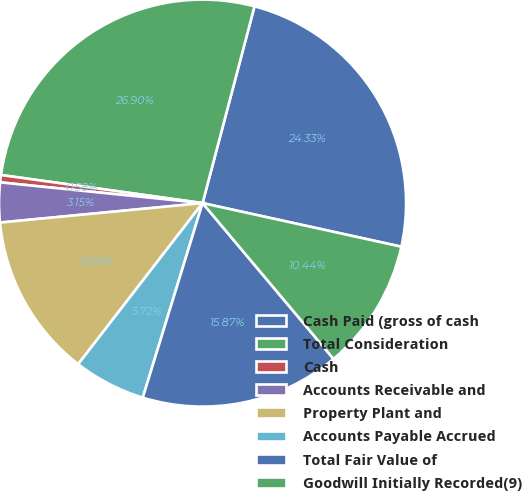Convert chart to OTSL. <chart><loc_0><loc_0><loc_500><loc_500><pie_chart><fcel>Cash Paid (gross of cash<fcel>Total Consideration<fcel>Cash<fcel>Accounts Receivable and<fcel>Property Plant and<fcel>Accounts Payable Accrued<fcel>Total Fair Value of<fcel>Goodwill Initially Recorded(9)<nl><fcel>24.33%<fcel>26.9%<fcel>0.58%<fcel>3.15%<fcel>13.01%<fcel>5.72%<fcel>15.87%<fcel>10.44%<nl></chart> 